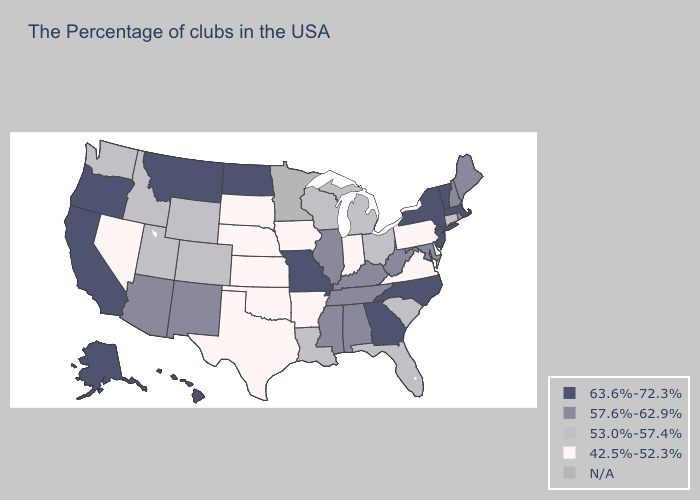What is the highest value in states that border South Dakota?
Quick response, please. 63.6%-72.3%. Does Alaska have the highest value in the USA?
Short answer required. Yes. Which states have the lowest value in the South?
Give a very brief answer. Delaware, Virginia, Arkansas, Oklahoma, Texas. What is the value of Michigan?
Concise answer only. 53.0%-57.4%. Does Nevada have the highest value in the West?
Short answer required. No. Which states have the lowest value in the USA?
Give a very brief answer. Delaware, Pennsylvania, Virginia, Indiana, Arkansas, Iowa, Kansas, Nebraska, Oklahoma, Texas, South Dakota, Nevada. Among the states that border Illinois , which have the highest value?
Keep it brief. Missouri. Does the first symbol in the legend represent the smallest category?
Concise answer only. No. Which states hav the highest value in the Northeast?
Write a very short answer. Massachusetts, Vermont, New York, New Jersey. Name the states that have a value in the range 57.6%-62.9%?
Give a very brief answer. Maine, Rhode Island, New Hampshire, Maryland, West Virginia, Kentucky, Alabama, Tennessee, Illinois, Mississippi, New Mexico, Arizona. Does Wyoming have the highest value in the USA?
Concise answer only. No. What is the lowest value in states that border Maine?
Give a very brief answer. 57.6%-62.9%. Is the legend a continuous bar?
Be succinct. No. 